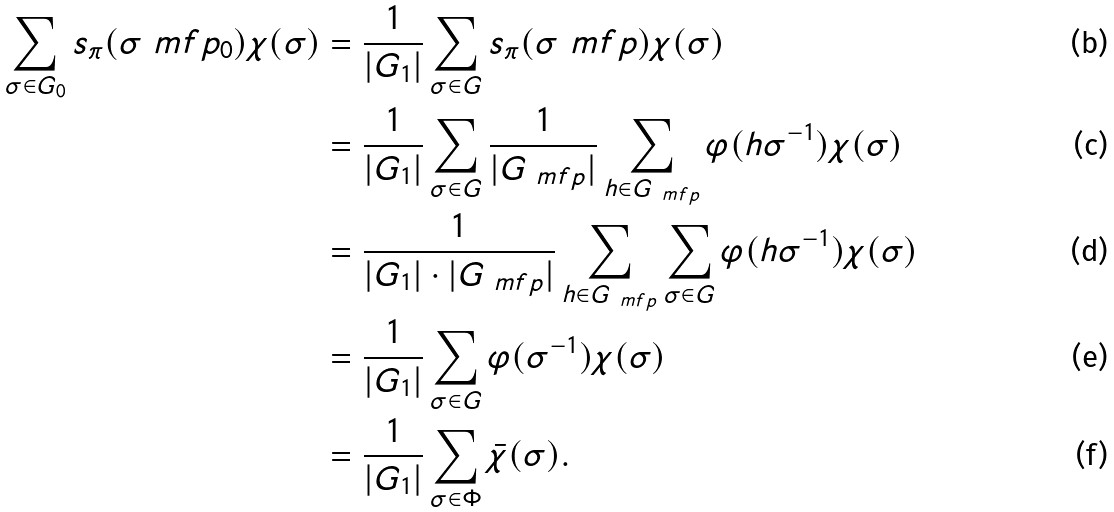<formula> <loc_0><loc_0><loc_500><loc_500>\sum _ { \sigma \in G _ { 0 } } s _ { \pi } ( \sigma \ m f { p } _ { 0 } ) \chi ( \sigma ) & = \frac { 1 } { | G _ { 1 } | } \sum _ { \sigma \in G } s _ { \pi } ( \sigma \ m f { p } ) \chi ( \sigma ) \\ & = \frac { 1 } { | G _ { 1 } | } \sum _ { \sigma \in G } \frac { 1 } { | G _ { { \ m f { p } } } | } \sum _ { h \in G _ { { \ m f { p } } } } \varphi ( h \sigma ^ { - 1 } ) \chi ( \sigma ) \\ & = \frac { 1 } { | G _ { 1 } | \cdot | G _ { { \ m f { p } } } | } \sum _ { h \in G _ { \ m f { p } } } \sum _ { \sigma \in G } \varphi ( h \sigma ^ { - 1 } ) \chi ( \sigma ) \\ & = \frac { 1 } { | G _ { 1 } | } \sum _ { \sigma \in G } \varphi ( \sigma ^ { - 1 } ) \chi ( \sigma ) \\ & = \frac { 1 } { | G _ { 1 } | } \sum _ { \sigma \in \Phi } \bar { \chi } ( \sigma ) .</formula> 